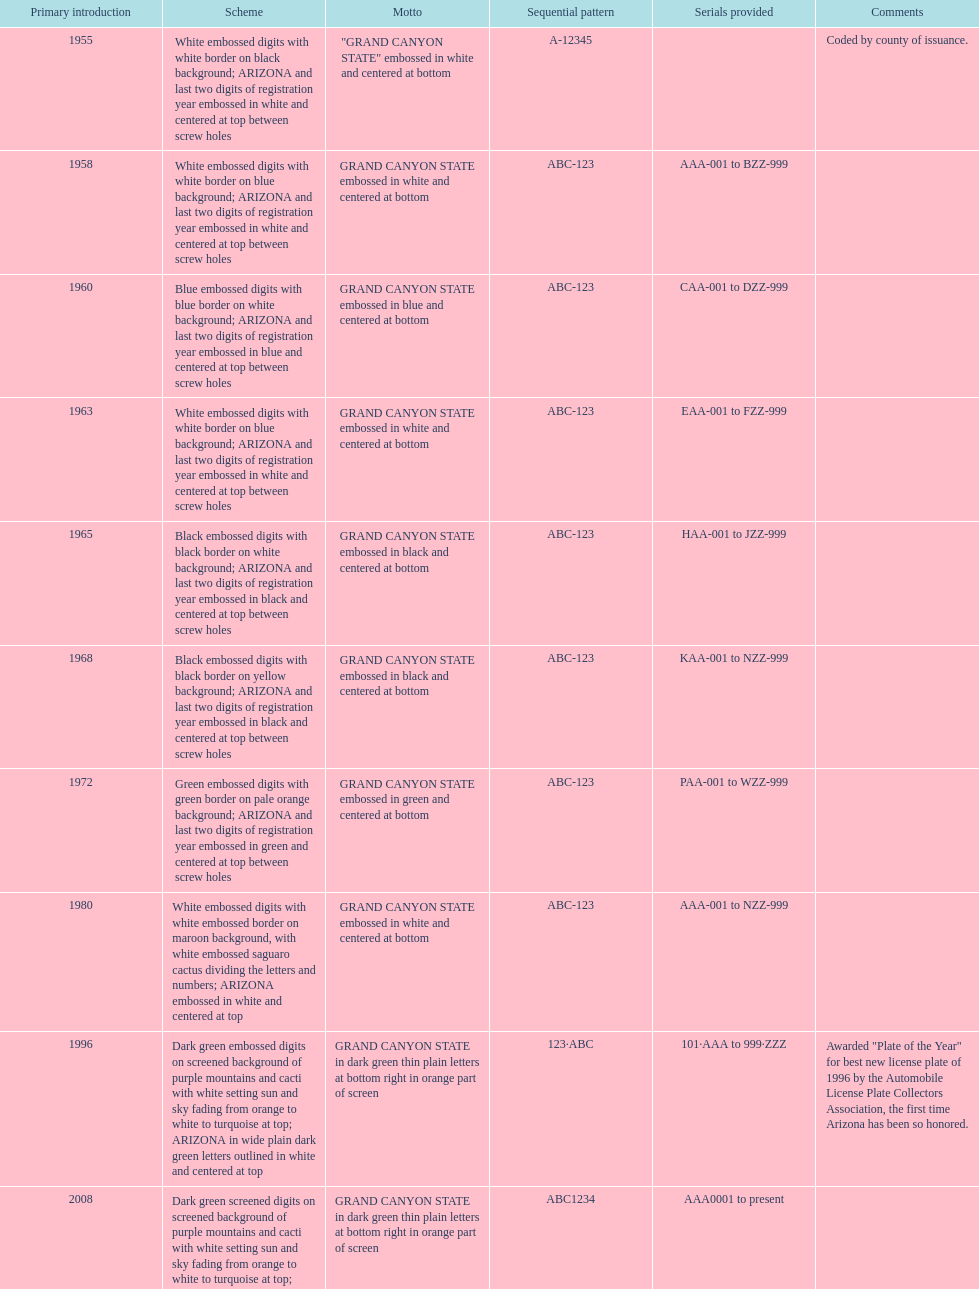What was year was the first arizona license plate made? 1955. 